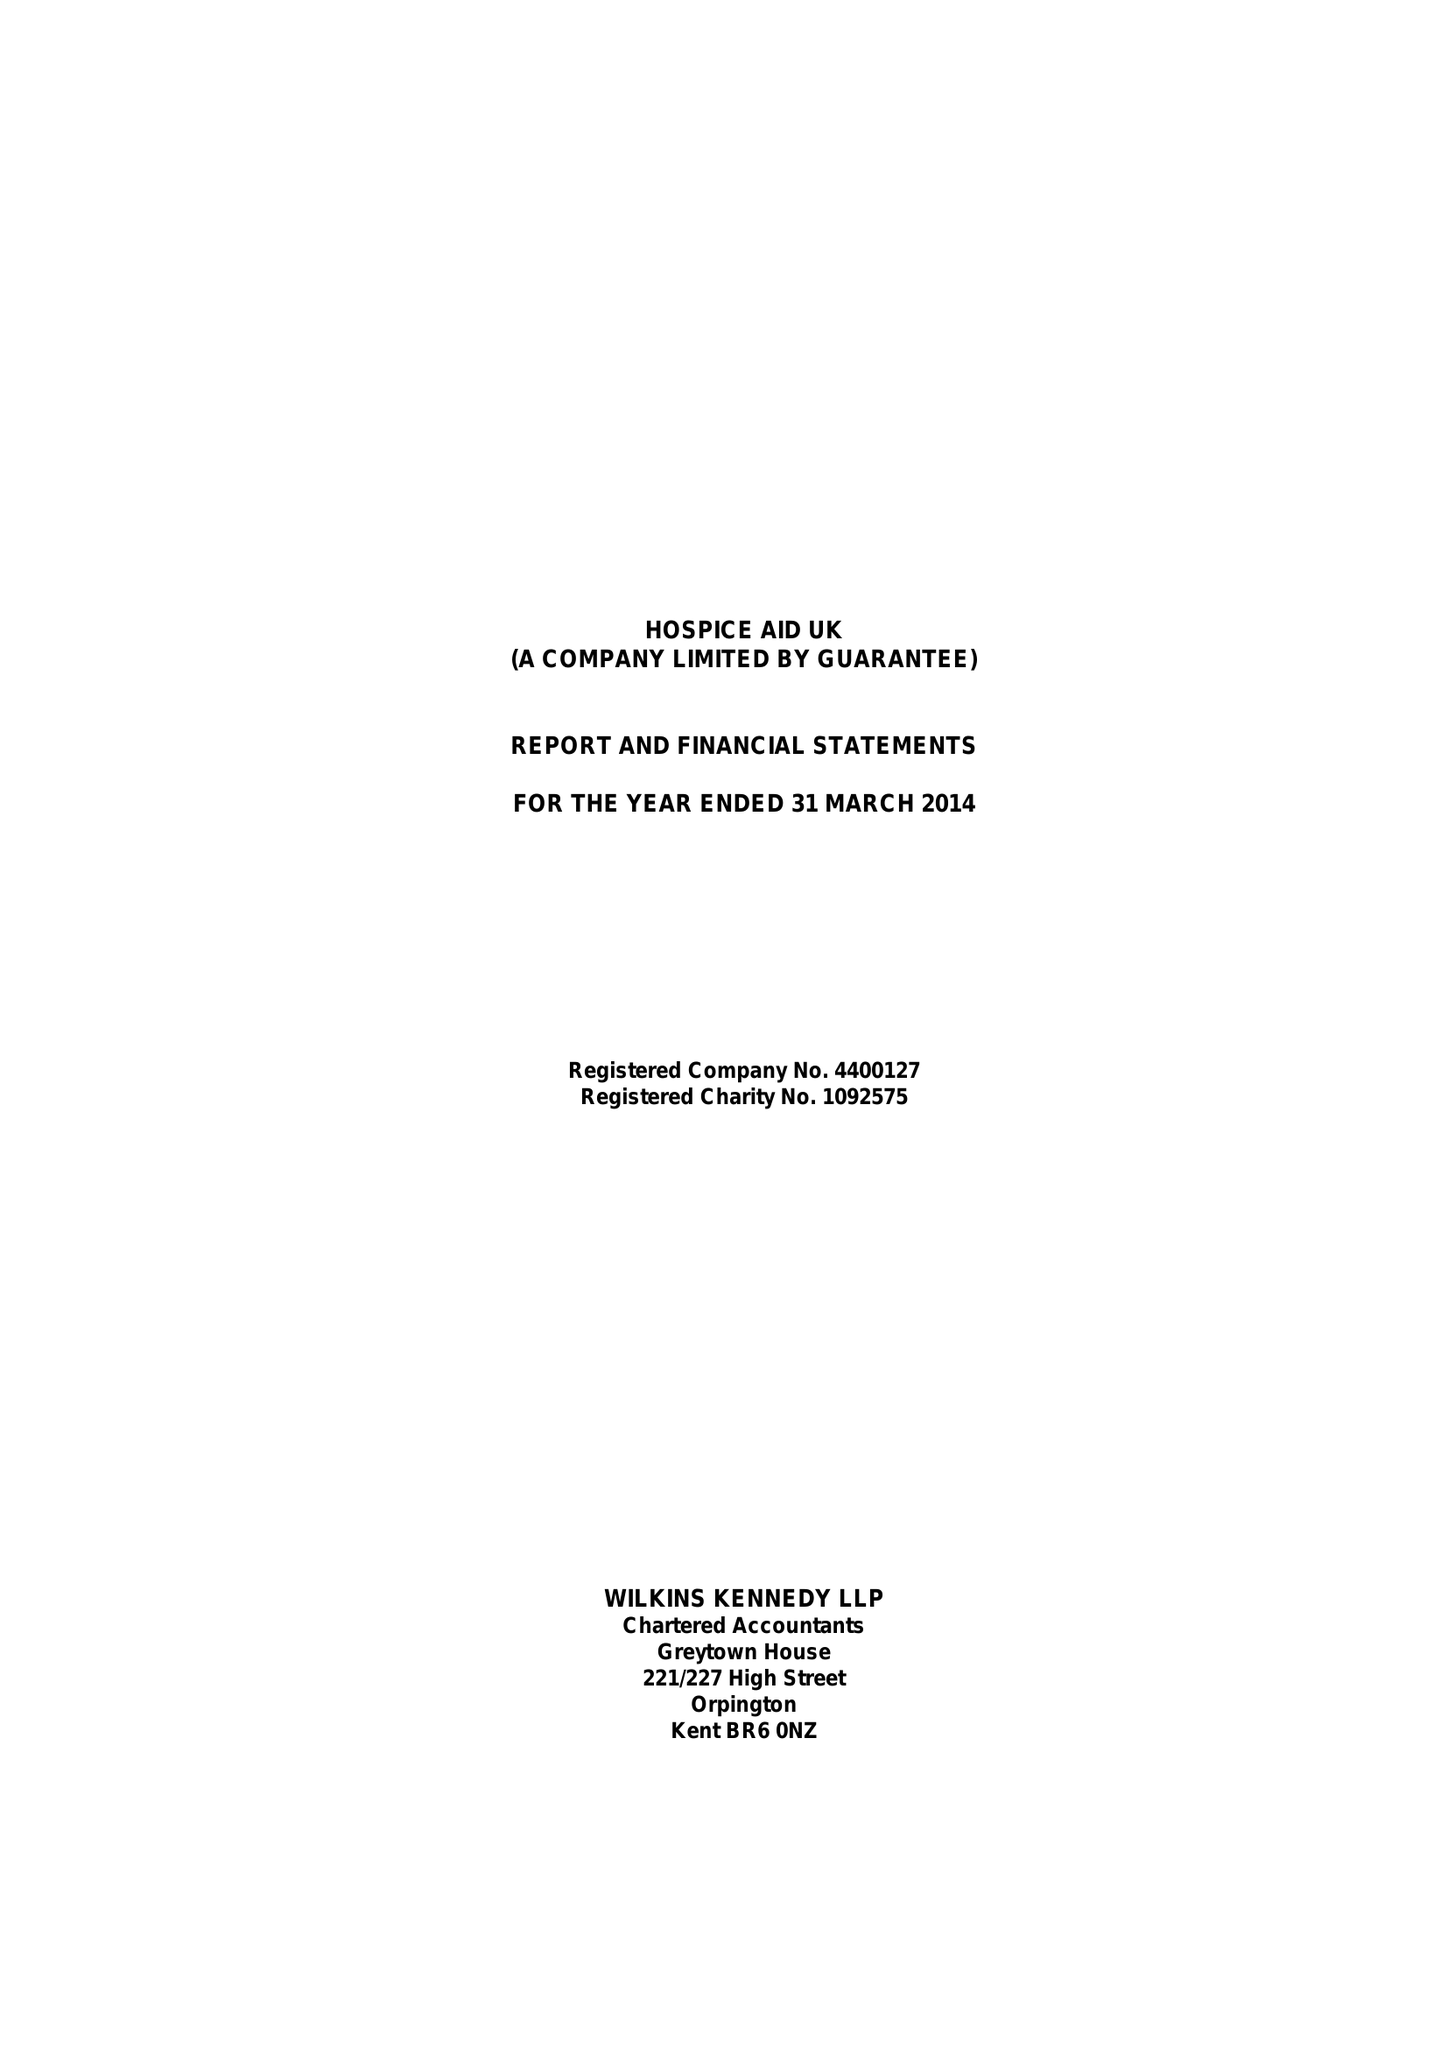What is the value for the address__street_line?
Answer the question using a single word or phrase. 1-7 STATION ROAD 